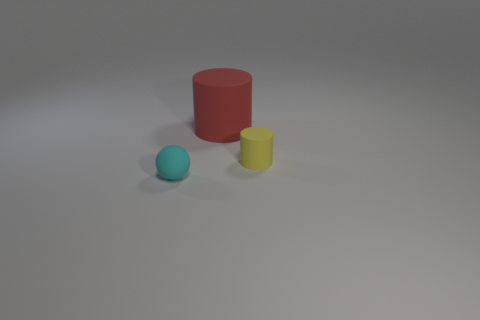Subtract all yellow cylinders. Subtract all red balls. How many cylinders are left? 1 Add 2 cyan metallic balls. How many objects exist? 5 Subtract all spheres. How many objects are left? 2 Subtract 1 red cylinders. How many objects are left? 2 Subtract all small yellow cylinders. Subtract all yellow objects. How many objects are left? 1 Add 1 cyan balls. How many cyan balls are left? 2 Add 1 small cyan things. How many small cyan things exist? 2 